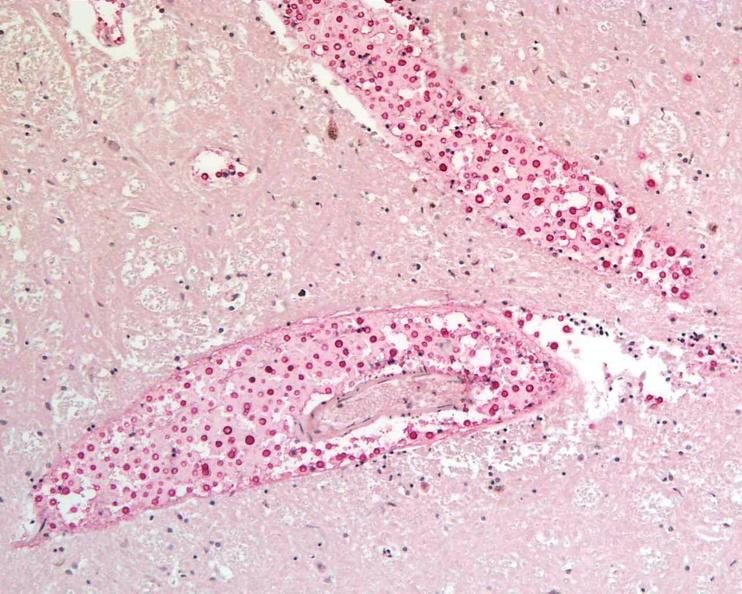do mucicarmine stain?
Answer the question using a single word or phrase. Yes 